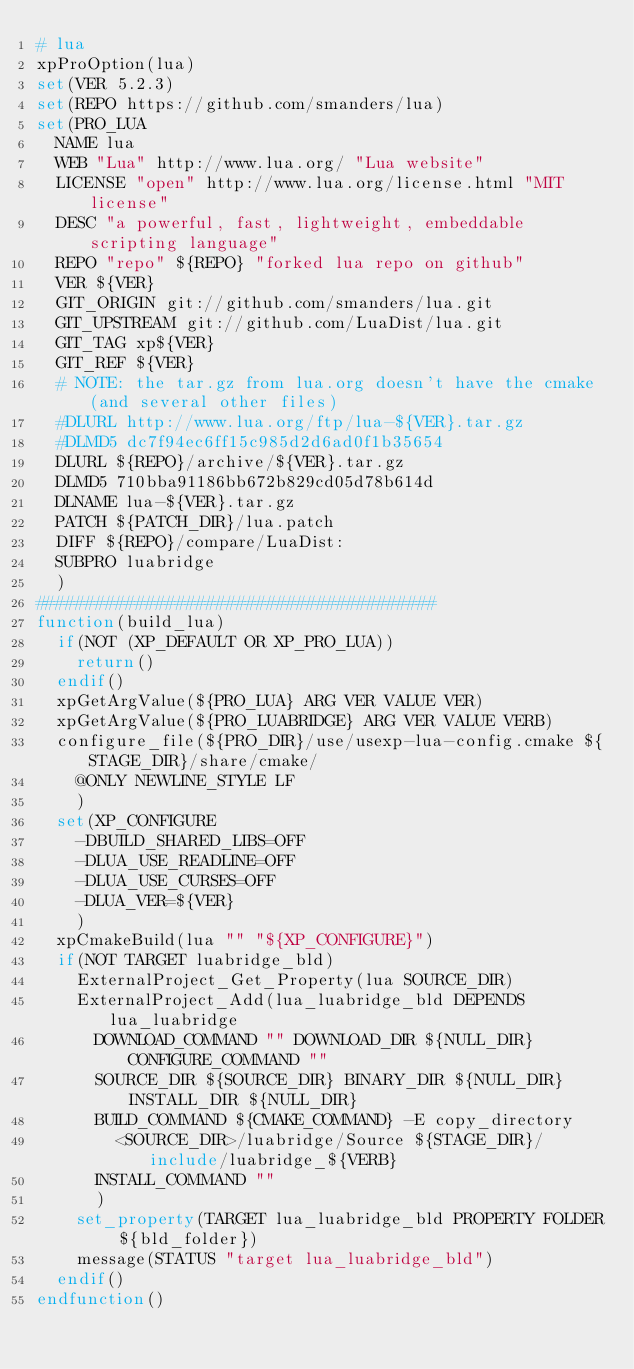<code> <loc_0><loc_0><loc_500><loc_500><_CMake_># lua
xpProOption(lua)
set(VER 5.2.3)
set(REPO https://github.com/smanders/lua)
set(PRO_LUA
  NAME lua
  WEB "Lua" http://www.lua.org/ "Lua website"
  LICENSE "open" http://www.lua.org/license.html "MIT license"
  DESC "a powerful, fast, lightweight, embeddable scripting language"
  REPO "repo" ${REPO} "forked lua repo on github"
  VER ${VER}
  GIT_ORIGIN git://github.com/smanders/lua.git
  GIT_UPSTREAM git://github.com/LuaDist/lua.git
  GIT_TAG xp${VER}
  GIT_REF ${VER}
  # NOTE: the tar.gz from lua.org doesn't have the cmake (and several other files)
  #DLURL http://www.lua.org/ftp/lua-${VER}.tar.gz
  #DLMD5 dc7f94ec6ff15c985d2d6ad0f1b35654
  DLURL ${REPO}/archive/${VER}.tar.gz
  DLMD5 710bba91186bb672b829cd05d78b614d
  DLNAME lua-${VER}.tar.gz
  PATCH ${PATCH_DIR}/lua.patch
  DIFF ${REPO}/compare/LuaDist:
  SUBPRO luabridge
  )
########################################
function(build_lua)
  if(NOT (XP_DEFAULT OR XP_PRO_LUA))
    return()
  endif()
  xpGetArgValue(${PRO_LUA} ARG VER VALUE VER)
  xpGetArgValue(${PRO_LUABRIDGE} ARG VER VALUE VERB)
  configure_file(${PRO_DIR}/use/usexp-lua-config.cmake ${STAGE_DIR}/share/cmake/
    @ONLY NEWLINE_STYLE LF
    )
  set(XP_CONFIGURE
    -DBUILD_SHARED_LIBS=OFF
    -DLUA_USE_READLINE=OFF
    -DLUA_USE_CURSES=OFF
    -DLUA_VER=${VER}
    )
  xpCmakeBuild(lua "" "${XP_CONFIGURE}")
  if(NOT TARGET luabridge_bld)
    ExternalProject_Get_Property(lua SOURCE_DIR)
    ExternalProject_Add(lua_luabridge_bld DEPENDS lua_luabridge
      DOWNLOAD_COMMAND "" DOWNLOAD_DIR ${NULL_DIR} CONFIGURE_COMMAND ""
      SOURCE_DIR ${SOURCE_DIR} BINARY_DIR ${NULL_DIR} INSTALL_DIR ${NULL_DIR}
      BUILD_COMMAND ${CMAKE_COMMAND} -E copy_directory
        <SOURCE_DIR>/luabridge/Source ${STAGE_DIR}/include/luabridge_${VERB}
      INSTALL_COMMAND ""
      )
    set_property(TARGET lua_luabridge_bld PROPERTY FOLDER ${bld_folder})
    message(STATUS "target lua_luabridge_bld")
  endif()
endfunction()
</code> 